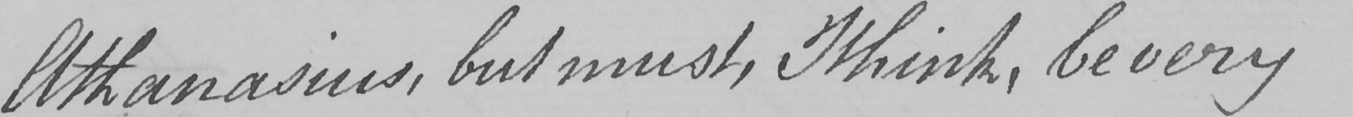Can you read and transcribe this handwriting? Athanasius , but must , I think , be very 